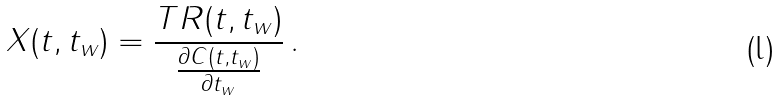Convert formula to latex. <formula><loc_0><loc_0><loc_500><loc_500>X ( t , t _ { w } ) = \frac { T R ( t , t _ { w } ) } { \frac { \partial C ( t , t _ { w } ) } { \partial t _ { w } } } \, .</formula> 